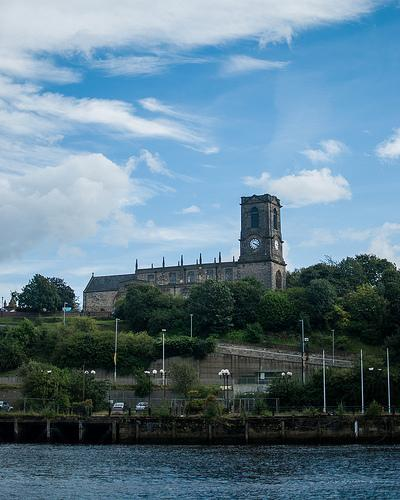Identify the main components of the image and their relationship with each other. There's a calm lake with clear, blue water by the parking lot, where cars are parked under tall lamp posts, in front of a large old stone building with a clock tower, bricks walls, and arches, all surrounded by green trees and hedges under a blue sky with white clouds. Describe the setting of the image and the atmosphere it evokes. The image features a peaceful lake by a parking lot with parked cars and tall lamp posts, adjacent to a beautiful and historic brick building with a clock tower, all under a blue sky with cottony white clouds, evoking a tranquil and serene atmosphere. Provide a detailed description of the primary focal point in the image. The brick clock tower, attached to a majestic stone building, features a large clock face reading twenty minutes past three, an arched window, and visible windows, signifying its historical importance and beauty. Summarize the scene depicted in the image in one sentence. This picturesque scene captures a tranquil lake by a parking lot in front of a historic brick building with a clock tower, all under a cloud-filled sky. Select three objects from the image and describe their appearance and purpose. The blue, rippling water in the lake reflects the sky, providing a serene environment; the clock tower on the brick building displays the time for anyone nearby, and the tall lamp posts illuminate the parking lot during the night for safety purposes. Mention five dominant objects in the image and their characteristics. Blue lake with clear water, tall lamp posts with white globes, cars parked in the lot, old stone clock tower building with multiple windows, and green trees surrounding the area. Examine the image for any signs of human activity and describe them. The parked cars in the parking lot indicate that there are people visiting the area, and the clock tower, as part of the stone building, suggests the presence of human architecture and design. List the primary colors seen in the image and three elements associated with them. Blue - lake and sky, Green - trees and hedges, White - clouds and lamp post globes. Describe three elements of nature depicted in the image and their visual appeal. The lake with its calm, blue rippling water creates a serene environment; the billowing white clouds scattered across the blue sky give a sense of tranquility; and the vibrant green trees surrounding the area add life and color to the scene. Provide a brief description of the most noticeable elements in the image. A serene blue lake lies next to a parking lot with cars and tall streetlights, which is near a brick clock tower building, all under a sky filled with fluffy white clouds. 